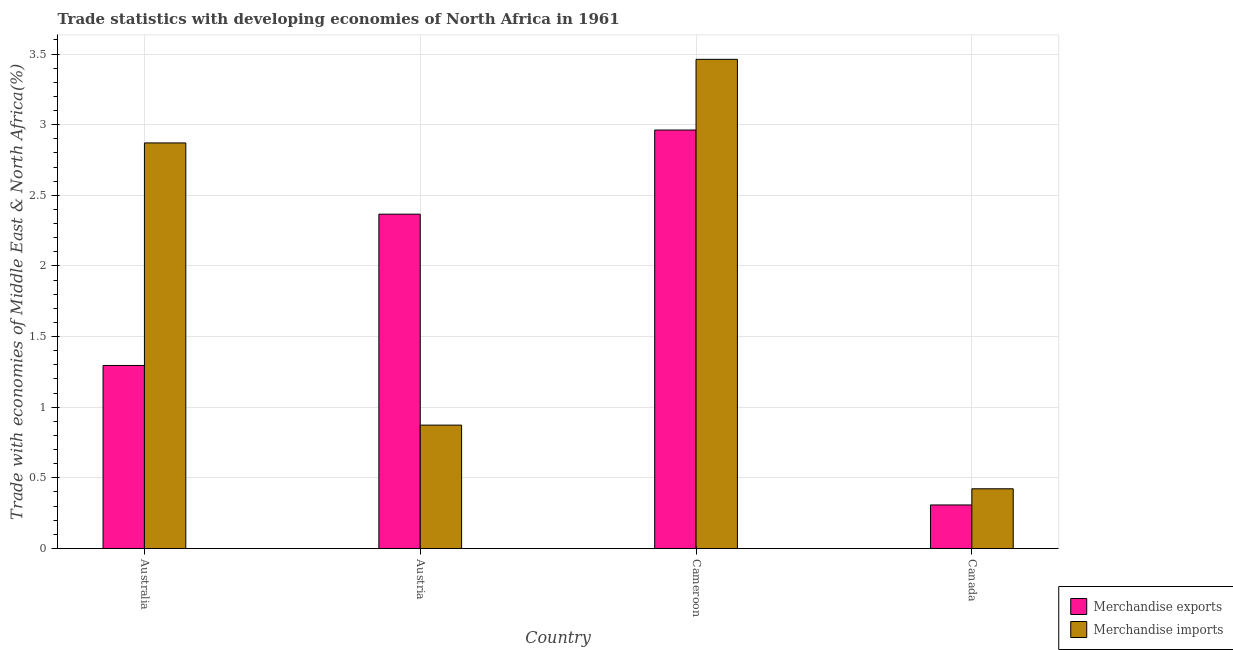How many groups of bars are there?
Give a very brief answer. 4. Are the number of bars per tick equal to the number of legend labels?
Offer a very short reply. Yes. How many bars are there on the 3rd tick from the left?
Your response must be concise. 2. How many bars are there on the 3rd tick from the right?
Your answer should be very brief. 2. What is the merchandise exports in Austria?
Provide a succinct answer. 2.37. Across all countries, what is the maximum merchandise imports?
Offer a very short reply. 3.46. Across all countries, what is the minimum merchandise exports?
Give a very brief answer. 0.31. In which country was the merchandise exports maximum?
Provide a succinct answer. Cameroon. In which country was the merchandise imports minimum?
Offer a very short reply. Canada. What is the total merchandise exports in the graph?
Your answer should be compact. 6.93. What is the difference between the merchandise exports in Austria and that in Canada?
Ensure brevity in your answer.  2.06. What is the difference between the merchandise exports in Austria and the merchandise imports in Cameroon?
Provide a short and direct response. -1.1. What is the average merchandise exports per country?
Keep it short and to the point. 1.73. What is the difference between the merchandise exports and merchandise imports in Austria?
Make the answer very short. 1.49. What is the ratio of the merchandise imports in Australia to that in Austria?
Your answer should be very brief. 3.29. What is the difference between the highest and the second highest merchandise exports?
Your answer should be very brief. 0.6. What is the difference between the highest and the lowest merchandise exports?
Offer a very short reply. 2.65. In how many countries, is the merchandise exports greater than the average merchandise exports taken over all countries?
Give a very brief answer. 2. How many countries are there in the graph?
Keep it short and to the point. 4. Are the values on the major ticks of Y-axis written in scientific E-notation?
Your answer should be very brief. No. Does the graph contain any zero values?
Make the answer very short. No. How many legend labels are there?
Make the answer very short. 2. What is the title of the graph?
Your response must be concise. Trade statistics with developing economies of North Africa in 1961. Does "Official creditors" appear as one of the legend labels in the graph?
Your answer should be compact. No. What is the label or title of the X-axis?
Your answer should be compact. Country. What is the label or title of the Y-axis?
Your answer should be very brief. Trade with economies of Middle East & North Africa(%). What is the Trade with economies of Middle East & North Africa(%) in Merchandise exports in Australia?
Provide a short and direct response. 1.3. What is the Trade with economies of Middle East & North Africa(%) of Merchandise imports in Australia?
Your answer should be very brief. 2.87. What is the Trade with economies of Middle East & North Africa(%) of Merchandise exports in Austria?
Provide a short and direct response. 2.37. What is the Trade with economies of Middle East & North Africa(%) of Merchandise imports in Austria?
Give a very brief answer. 0.87. What is the Trade with economies of Middle East & North Africa(%) in Merchandise exports in Cameroon?
Give a very brief answer. 2.96. What is the Trade with economies of Middle East & North Africa(%) in Merchandise imports in Cameroon?
Offer a very short reply. 3.46. What is the Trade with economies of Middle East & North Africa(%) of Merchandise exports in Canada?
Provide a succinct answer. 0.31. What is the Trade with economies of Middle East & North Africa(%) of Merchandise imports in Canada?
Your response must be concise. 0.42. Across all countries, what is the maximum Trade with economies of Middle East & North Africa(%) of Merchandise exports?
Provide a succinct answer. 2.96. Across all countries, what is the maximum Trade with economies of Middle East & North Africa(%) of Merchandise imports?
Give a very brief answer. 3.46. Across all countries, what is the minimum Trade with economies of Middle East & North Africa(%) in Merchandise exports?
Offer a very short reply. 0.31. Across all countries, what is the minimum Trade with economies of Middle East & North Africa(%) in Merchandise imports?
Offer a terse response. 0.42. What is the total Trade with economies of Middle East & North Africa(%) of Merchandise exports in the graph?
Ensure brevity in your answer.  6.93. What is the total Trade with economies of Middle East & North Africa(%) of Merchandise imports in the graph?
Provide a short and direct response. 7.63. What is the difference between the Trade with economies of Middle East & North Africa(%) in Merchandise exports in Australia and that in Austria?
Keep it short and to the point. -1.07. What is the difference between the Trade with economies of Middle East & North Africa(%) of Merchandise imports in Australia and that in Austria?
Provide a short and direct response. 2. What is the difference between the Trade with economies of Middle East & North Africa(%) of Merchandise exports in Australia and that in Cameroon?
Your response must be concise. -1.67. What is the difference between the Trade with economies of Middle East & North Africa(%) in Merchandise imports in Australia and that in Cameroon?
Give a very brief answer. -0.59. What is the difference between the Trade with economies of Middle East & North Africa(%) of Merchandise exports in Australia and that in Canada?
Make the answer very short. 0.99. What is the difference between the Trade with economies of Middle East & North Africa(%) of Merchandise imports in Australia and that in Canada?
Give a very brief answer. 2.45. What is the difference between the Trade with economies of Middle East & North Africa(%) in Merchandise exports in Austria and that in Cameroon?
Make the answer very short. -0.6. What is the difference between the Trade with economies of Middle East & North Africa(%) of Merchandise imports in Austria and that in Cameroon?
Your response must be concise. -2.59. What is the difference between the Trade with economies of Middle East & North Africa(%) in Merchandise exports in Austria and that in Canada?
Your answer should be compact. 2.06. What is the difference between the Trade with economies of Middle East & North Africa(%) of Merchandise imports in Austria and that in Canada?
Make the answer very short. 0.45. What is the difference between the Trade with economies of Middle East & North Africa(%) in Merchandise exports in Cameroon and that in Canada?
Provide a succinct answer. 2.65. What is the difference between the Trade with economies of Middle East & North Africa(%) in Merchandise imports in Cameroon and that in Canada?
Provide a succinct answer. 3.04. What is the difference between the Trade with economies of Middle East & North Africa(%) in Merchandise exports in Australia and the Trade with economies of Middle East & North Africa(%) in Merchandise imports in Austria?
Provide a short and direct response. 0.42. What is the difference between the Trade with economies of Middle East & North Africa(%) in Merchandise exports in Australia and the Trade with economies of Middle East & North Africa(%) in Merchandise imports in Cameroon?
Offer a very short reply. -2.17. What is the difference between the Trade with economies of Middle East & North Africa(%) of Merchandise exports in Australia and the Trade with economies of Middle East & North Africa(%) of Merchandise imports in Canada?
Provide a succinct answer. 0.87. What is the difference between the Trade with economies of Middle East & North Africa(%) of Merchandise exports in Austria and the Trade with economies of Middle East & North Africa(%) of Merchandise imports in Cameroon?
Ensure brevity in your answer.  -1.1. What is the difference between the Trade with economies of Middle East & North Africa(%) in Merchandise exports in Austria and the Trade with economies of Middle East & North Africa(%) in Merchandise imports in Canada?
Offer a terse response. 1.94. What is the difference between the Trade with economies of Middle East & North Africa(%) in Merchandise exports in Cameroon and the Trade with economies of Middle East & North Africa(%) in Merchandise imports in Canada?
Provide a short and direct response. 2.54. What is the average Trade with economies of Middle East & North Africa(%) of Merchandise exports per country?
Offer a very short reply. 1.73. What is the average Trade with economies of Middle East & North Africa(%) of Merchandise imports per country?
Your answer should be compact. 1.91. What is the difference between the Trade with economies of Middle East & North Africa(%) of Merchandise exports and Trade with economies of Middle East & North Africa(%) of Merchandise imports in Australia?
Ensure brevity in your answer.  -1.58. What is the difference between the Trade with economies of Middle East & North Africa(%) in Merchandise exports and Trade with economies of Middle East & North Africa(%) in Merchandise imports in Austria?
Your response must be concise. 1.49. What is the difference between the Trade with economies of Middle East & North Africa(%) of Merchandise exports and Trade with economies of Middle East & North Africa(%) of Merchandise imports in Cameroon?
Your answer should be very brief. -0.5. What is the difference between the Trade with economies of Middle East & North Africa(%) of Merchandise exports and Trade with economies of Middle East & North Africa(%) of Merchandise imports in Canada?
Give a very brief answer. -0.11. What is the ratio of the Trade with economies of Middle East & North Africa(%) of Merchandise exports in Australia to that in Austria?
Give a very brief answer. 0.55. What is the ratio of the Trade with economies of Middle East & North Africa(%) of Merchandise imports in Australia to that in Austria?
Provide a short and direct response. 3.29. What is the ratio of the Trade with economies of Middle East & North Africa(%) in Merchandise exports in Australia to that in Cameroon?
Your answer should be compact. 0.44. What is the ratio of the Trade with economies of Middle East & North Africa(%) of Merchandise imports in Australia to that in Cameroon?
Make the answer very short. 0.83. What is the ratio of the Trade with economies of Middle East & North Africa(%) of Merchandise exports in Australia to that in Canada?
Your answer should be very brief. 4.21. What is the ratio of the Trade with economies of Middle East & North Africa(%) in Merchandise imports in Australia to that in Canada?
Offer a terse response. 6.79. What is the ratio of the Trade with economies of Middle East & North Africa(%) in Merchandise exports in Austria to that in Cameroon?
Make the answer very short. 0.8. What is the ratio of the Trade with economies of Middle East & North Africa(%) in Merchandise imports in Austria to that in Cameroon?
Your answer should be very brief. 0.25. What is the ratio of the Trade with economies of Middle East & North Africa(%) of Merchandise exports in Austria to that in Canada?
Offer a very short reply. 7.68. What is the ratio of the Trade with economies of Middle East & North Africa(%) of Merchandise imports in Austria to that in Canada?
Give a very brief answer. 2.07. What is the ratio of the Trade with economies of Middle East & North Africa(%) of Merchandise exports in Cameroon to that in Canada?
Provide a short and direct response. 9.61. What is the ratio of the Trade with economies of Middle East & North Africa(%) of Merchandise imports in Cameroon to that in Canada?
Ensure brevity in your answer.  8.19. What is the difference between the highest and the second highest Trade with economies of Middle East & North Africa(%) in Merchandise exports?
Your answer should be compact. 0.6. What is the difference between the highest and the second highest Trade with economies of Middle East & North Africa(%) in Merchandise imports?
Offer a terse response. 0.59. What is the difference between the highest and the lowest Trade with economies of Middle East & North Africa(%) in Merchandise exports?
Ensure brevity in your answer.  2.65. What is the difference between the highest and the lowest Trade with economies of Middle East & North Africa(%) of Merchandise imports?
Offer a very short reply. 3.04. 